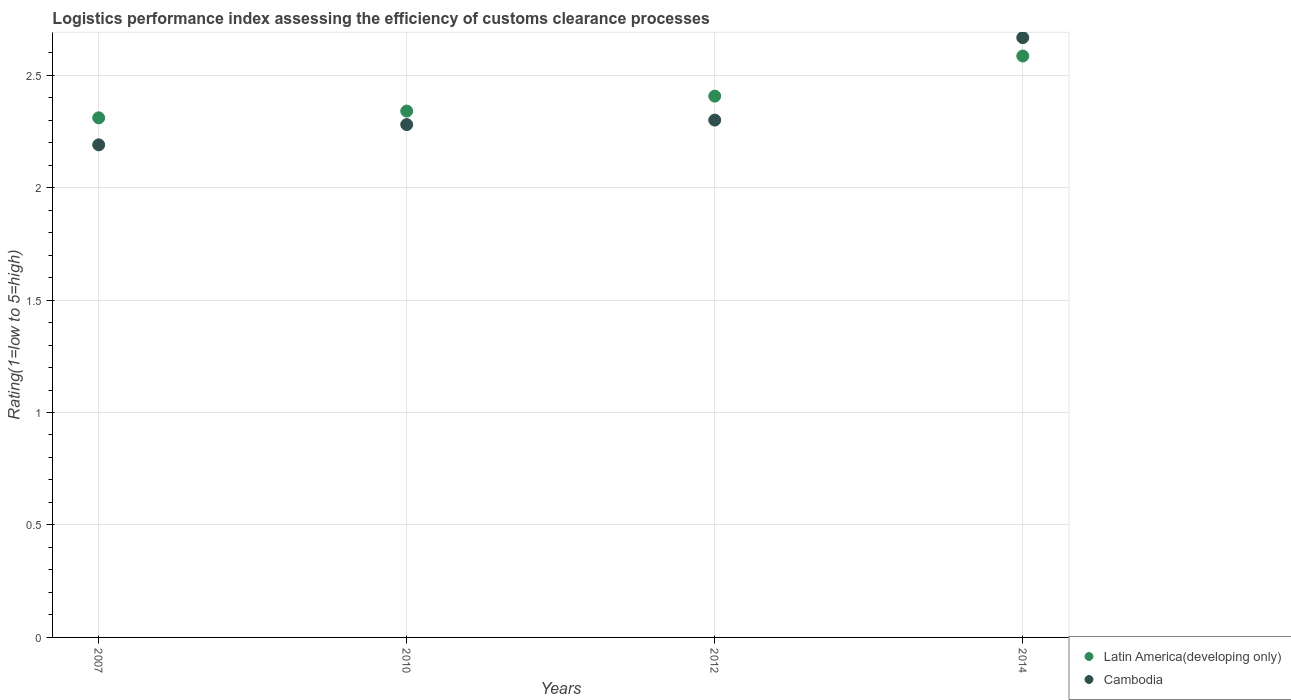How many different coloured dotlines are there?
Make the answer very short. 2. Is the number of dotlines equal to the number of legend labels?
Provide a short and direct response. Yes. What is the Logistic performance index in Latin America(developing only) in 2014?
Give a very brief answer. 2.58. Across all years, what is the maximum Logistic performance index in Cambodia?
Provide a short and direct response. 2.67. Across all years, what is the minimum Logistic performance index in Latin America(developing only)?
Provide a succinct answer. 2.31. In which year was the Logistic performance index in Latin America(developing only) minimum?
Give a very brief answer. 2007. What is the total Logistic performance index in Cambodia in the graph?
Offer a terse response. 9.44. What is the difference between the Logistic performance index in Latin America(developing only) in 2010 and that in 2014?
Offer a terse response. -0.24. What is the difference between the Logistic performance index in Latin America(developing only) in 2010 and the Logistic performance index in Cambodia in 2012?
Give a very brief answer. 0.04. What is the average Logistic performance index in Cambodia per year?
Your response must be concise. 2.36. In the year 2010, what is the difference between the Logistic performance index in Latin America(developing only) and Logistic performance index in Cambodia?
Make the answer very short. 0.06. What is the ratio of the Logistic performance index in Cambodia in 2010 to that in 2012?
Provide a succinct answer. 0.99. Is the Logistic performance index in Cambodia in 2010 less than that in 2014?
Provide a short and direct response. Yes. Is the difference between the Logistic performance index in Latin America(developing only) in 2012 and 2014 greater than the difference between the Logistic performance index in Cambodia in 2012 and 2014?
Provide a short and direct response. Yes. What is the difference between the highest and the second highest Logistic performance index in Cambodia?
Provide a short and direct response. 0.37. What is the difference between the highest and the lowest Logistic performance index in Latin America(developing only)?
Your answer should be compact. 0.27. Is the Logistic performance index in Latin America(developing only) strictly less than the Logistic performance index in Cambodia over the years?
Your response must be concise. No. How many dotlines are there?
Your answer should be very brief. 2. Does the graph contain grids?
Your answer should be very brief. Yes. How many legend labels are there?
Your answer should be compact. 2. How are the legend labels stacked?
Offer a terse response. Vertical. What is the title of the graph?
Your response must be concise. Logistics performance index assessing the efficiency of customs clearance processes. What is the label or title of the X-axis?
Keep it short and to the point. Years. What is the label or title of the Y-axis?
Your answer should be compact. Rating(1=low to 5=high). What is the Rating(1=low to 5=high) of Latin America(developing only) in 2007?
Provide a short and direct response. 2.31. What is the Rating(1=low to 5=high) in Cambodia in 2007?
Offer a very short reply. 2.19. What is the Rating(1=low to 5=high) in Latin America(developing only) in 2010?
Your answer should be compact. 2.34. What is the Rating(1=low to 5=high) in Cambodia in 2010?
Your response must be concise. 2.28. What is the Rating(1=low to 5=high) of Latin America(developing only) in 2012?
Keep it short and to the point. 2.41. What is the Rating(1=low to 5=high) in Cambodia in 2012?
Provide a short and direct response. 2.3. What is the Rating(1=low to 5=high) of Latin America(developing only) in 2014?
Your response must be concise. 2.58. What is the Rating(1=low to 5=high) in Cambodia in 2014?
Keep it short and to the point. 2.67. Across all years, what is the maximum Rating(1=low to 5=high) of Latin America(developing only)?
Your answer should be very brief. 2.58. Across all years, what is the maximum Rating(1=low to 5=high) of Cambodia?
Give a very brief answer. 2.67. Across all years, what is the minimum Rating(1=low to 5=high) of Latin America(developing only)?
Your response must be concise. 2.31. Across all years, what is the minimum Rating(1=low to 5=high) of Cambodia?
Your answer should be compact. 2.19. What is the total Rating(1=low to 5=high) in Latin America(developing only) in the graph?
Provide a short and direct response. 9.64. What is the total Rating(1=low to 5=high) of Cambodia in the graph?
Give a very brief answer. 9.44. What is the difference between the Rating(1=low to 5=high) of Latin America(developing only) in 2007 and that in 2010?
Ensure brevity in your answer.  -0.03. What is the difference between the Rating(1=low to 5=high) of Cambodia in 2007 and that in 2010?
Your answer should be compact. -0.09. What is the difference between the Rating(1=low to 5=high) of Latin America(developing only) in 2007 and that in 2012?
Provide a short and direct response. -0.1. What is the difference between the Rating(1=low to 5=high) in Cambodia in 2007 and that in 2012?
Give a very brief answer. -0.11. What is the difference between the Rating(1=low to 5=high) in Latin America(developing only) in 2007 and that in 2014?
Make the answer very short. -0.27. What is the difference between the Rating(1=low to 5=high) of Cambodia in 2007 and that in 2014?
Offer a terse response. -0.48. What is the difference between the Rating(1=low to 5=high) of Latin America(developing only) in 2010 and that in 2012?
Your answer should be compact. -0.07. What is the difference between the Rating(1=low to 5=high) of Cambodia in 2010 and that in 2012?
Your response must be concise. -0.02. What is the difference between the Rating(1=low to 5=high) in Latin America(developing only) in 2010 and that in 2014?
Your answer should be very brief. -0.24. What is the difference between the Rating(1=low to 5=high) in Cambodia in 2010 and that in 2014?
Keep it short and to the point. -0.39. What is the difference between the Rating(1=low to 5=high) of Latin America(developing only) in 2012 and that in 2014?
Your response must be concise. -0.18. What is the difference between the Rating(1=low to 5=high) of Cambodia in 2012 and that in 2014?
Make the answer very short. -0.37. What is the difference between the Rating(1=low to 5=high) of Latin America(developing only) in 2007 and the Rating(1=low to 5=high) of Cambodia in 2012?
Offer a terse response. 0.01. What is the difference between the Rating(1=low to 5=high) in Latin America(developing only) in 2007 and the Rating(1=low to 5=high) in Cambodia in 2014?
Offer a terse response. -0.36. What is the difference between the Rating(1=low to 5=high) of Latin America(developing only) in 2010 and the Rating(1=low to 5=high) of Cambodia in 2012?
Your response must be concise. 0.04. What is the difference between the Rating(1=low to 5=high) in Latin America(developing only) in 2010 and the Rating(1=low to 5=high) in Cambodia in 2014?
Your answer should be compact. -0.33. What is the difference between the Rating(1=low to 5=high) in Latin America(developing only) in 2012 and the Rating(1=low to 5=high) in Cambodia in 2014?
Your answer should be very brief. -0.26. What is the average Rating(1=low to 5=high) of Latin America(developing only) per year?
Keep it short and to the point. 2.41. What is the average Rating(1=low to 5=high) of Cambodia per year?
Provide a succinct answer. 2.36. In the year 2007, what is the difference between the Rating(1=low to 5=high) of Latin America(developing only) and Rating(1=low to 5=high) of Cambodia?
Make the answer very short. 0.12. In the year 2012, what is the difference between the Rating(1=low to 5=high) of Latin America(developing only) and Rating(1=low to 5=high) of Cambodia?
Ensure brevity in your answer.  0.11. In the year 2014, what is the difference between the Rating(1=low to 5=high) of Latin America(developing only) and Rating(1=low to 5=high) of Cambodia?
Give a very brief answer. -0.08. What is the ratio of the Rating(1=low to 5=high) in Latin America(developing only) in 2007 to that in 2010?
Offer a very short reply. 0.99. What is the ratio of the Rating(1=low to 5=high) of Cambodia in 2007 to that in 2010?
Provide a succinct answer. 0.96. What is the ratio of the Rating(1=low to 5=high) of Latin America(developing only) in 2007 to that in 2012?
Your answer should be compact. 0.96. What is the ratio of the Rating(1=low to 5=high) of Cambodia in 2007 to that in 2012?
Ensure brevity in your answer.  0.95. What is the ratio of the Rating(1=low to 5=high) in Latin America(developing only) in 2007 to that in 2014?
Offer a terse response. 0.89. What is the ratio of the Rating(1=low to 5=high) in Cambodia in 2007 to that in 2014?
Your response must be concise. 0.82. What is the ratio of the Rating(1=low to 5=high) of Latin America(developing only) in 2010 to that in 2012?
Provide a short and direct response. 0.97. What is the ratio of the Rating(1=low to 5=high) in Cambodia in 2010 to that in 2012?
Keep it short and to the point. 0.99. What is the ratio of the Rating(1=low to 5=high) of Latin America(developing only) in 2010 to that in 2014?
Your answer should be very brief. 0.91. What is the ratio of the Rating(1=low to 5=high) in Cambodia in 2010 to that in 2014?
Make the answer very short. 0.85. What is the ratio of the Rating(1=low to 5=high) of Cambodia in 2012 to that in 2014?
Keep it short and to the point. 0.86. What is the difference between the highest and the second highest Rating(1=low to 5=high) of Latin America(developing only)?
Provide a succinct answer. 0.18. What is the difference between the highest and the second highest Rating(1=low to 5=high) in Cambodia?
Offer a terse response. 0.37. What is the difference between the highest and the lowest Rating(1=low to 5=high) in Latin America(developing only)?
Your answer should be very brief. 0.27. What is the difference between the highest and the lowest Rating(1=low to 5=high) in Cambodia?
Make the answer very short. 0.48. 